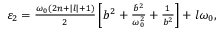<formula> <loc_0><loc_0><loc_500><loc_500>\begin{array} { r } { \varepsilon _ { 2 } = \frac { \omega _ { 0 } ( 2 n + | l | + 1 ) } { 2 } \left [ b ^ { 2 } + \frac { \dot { b } ^ { 2 } } { \omega _ { 0 } ^ { 2 } } + \frac { 1 } { b ^ { 2 } } \right ] + l \omega _ { 0 } , } \end{array}</formula> 